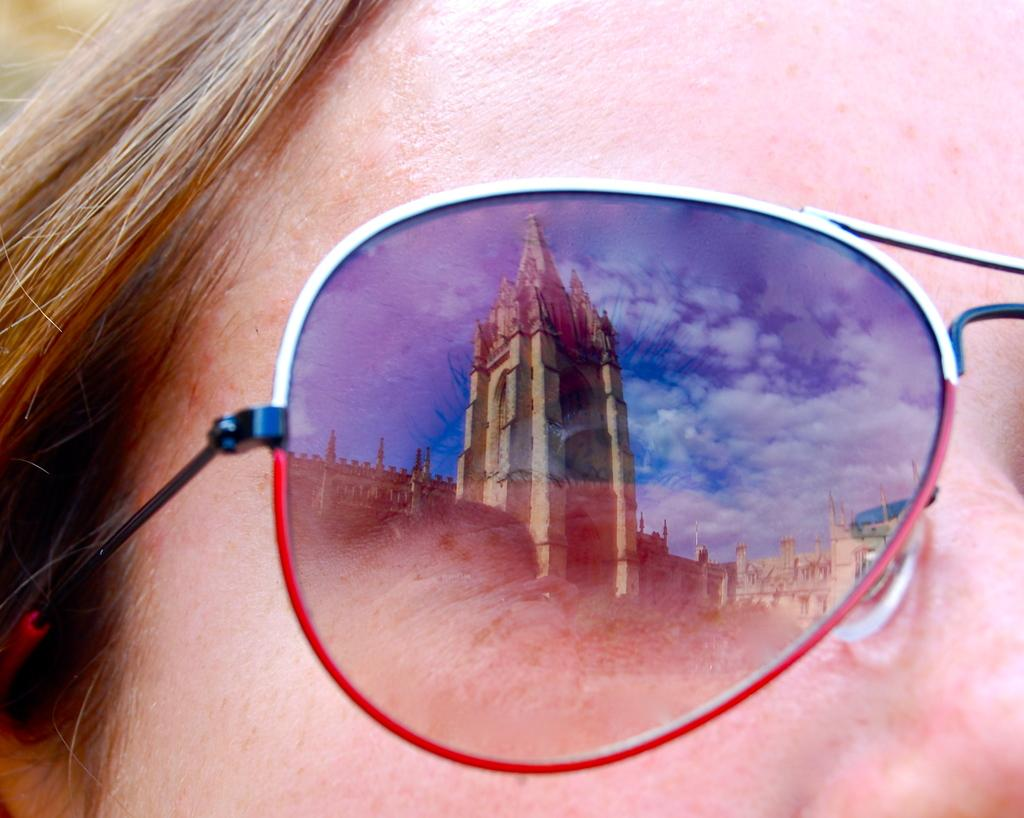Who is present in the image? There is a woman in the image. What is the woman wearing on her face? The woman is wearing goggles. What can be seen in the reflection of the goggles? The reflection of a building and the sky can be seen in the goggles. What type of substance is being served for dinner in the image? There is no dinner or substance being served in the image; it primarily features a woman wearing goggles with reflections of a building and the sky. 